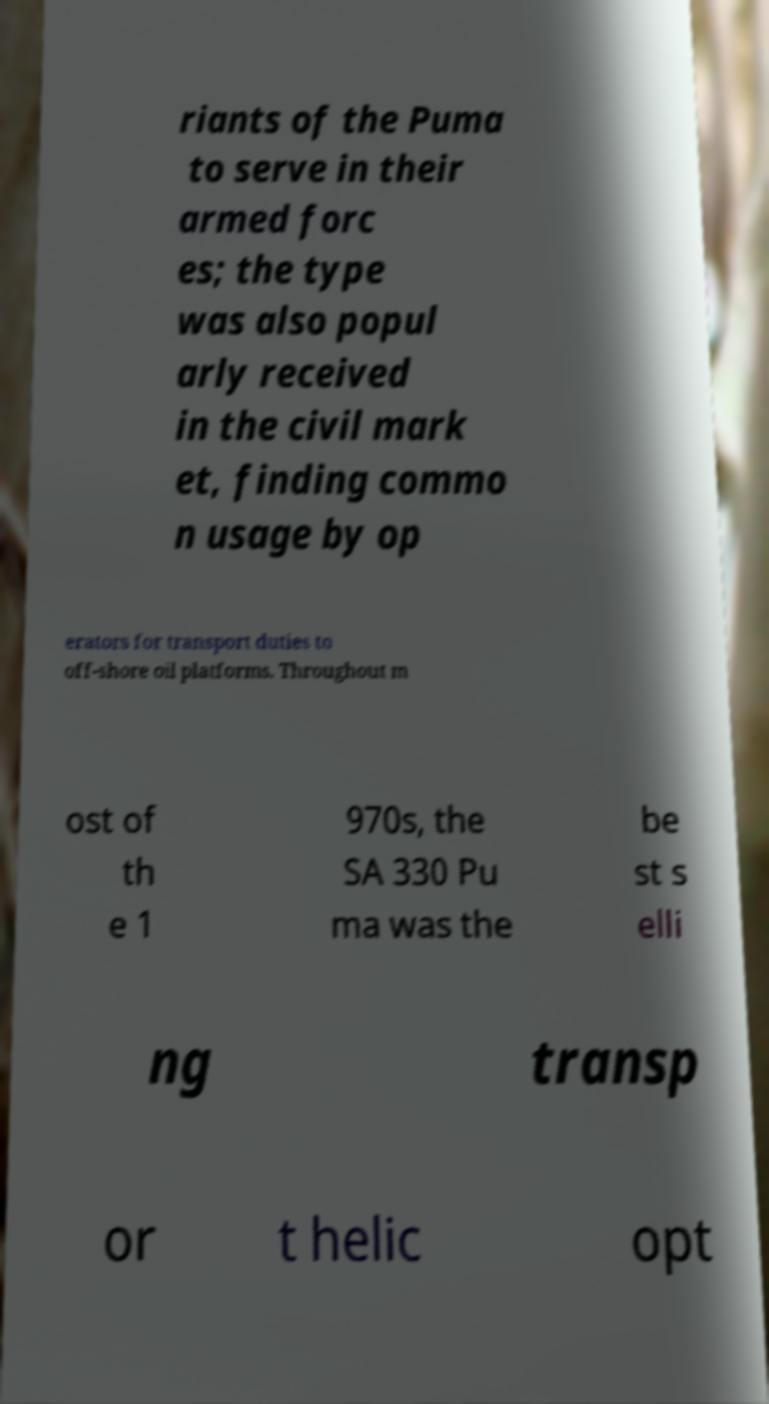There's text embedded in this image that I need extracted. Can you transcribe it verbatim? riants of the Puma to serve in their armed forc es; the type was also popul arly received in the civil mark et, finding commo n usage by op erators for transport duties to off-shore oil platforms. Throughout m ost of th e 1 970s, the SA 330 Pu ma was the be st s elli ng transp or t helic opt 